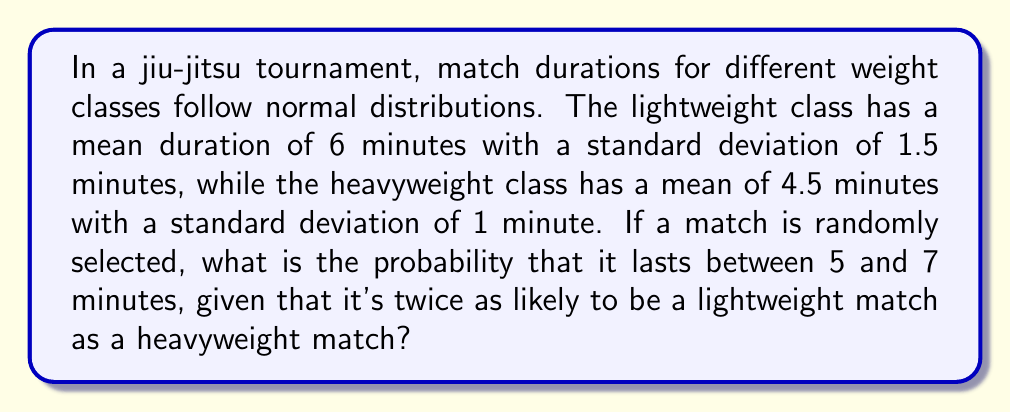Help me with this question. Let's approach this step-by-step:

1) Let L be the event of selecting a lightweight match, and H be the event of selecting a heavyweight match.
   Given: P(L) = 2P(H) and P(L) + P(H) = 1
   Solving: P(L) = 2/3, P(H) = 1/3

2) For lightweight matches:
   Mean (μ_L) = 6 minutes, Standard deviation (σ_L) = 1.5 minutes

3) For heavyweight matches:
   Mean (μ_H) = 4.5 minutes, Standard deviation (σ_H) = 1 minute

4) We need to find P(5 < X < 7), where X is the match duration.

5) For lightweight matches:
   Z_L(5) = (5 - 6) / 1.5 = -0.67
   Z_L(7) = (7 - 6) / 1.5 = 0.67
   P(5 < X < 7 | L) = Φ(0.67) - Φ(-0.67) = 0.7486 - 0.2514 = 0.4972

6) For heavyweight matches:
   Z_H(5) = (5 - 4.5) / 1 = 0.5
   Z_H(7) = (7 - 4.5) / 1 = 2.5
   P(5 < X < 7 | H) = Φ(2.5) - Φ(0.5) = 0.9938 - 0.6915 = 0.3023

7) Using the law of total probability:
   P(5 < X < 7) = P(L) * P(5 < X < 7 | L) + P(H) * P(5 < X < 7 | H)
                = (2/3 * 0.4972) + (1/3 * 0.3023)
                = 0.3314 + 0.1008
                = 0.4322
Answer: 0.4322 